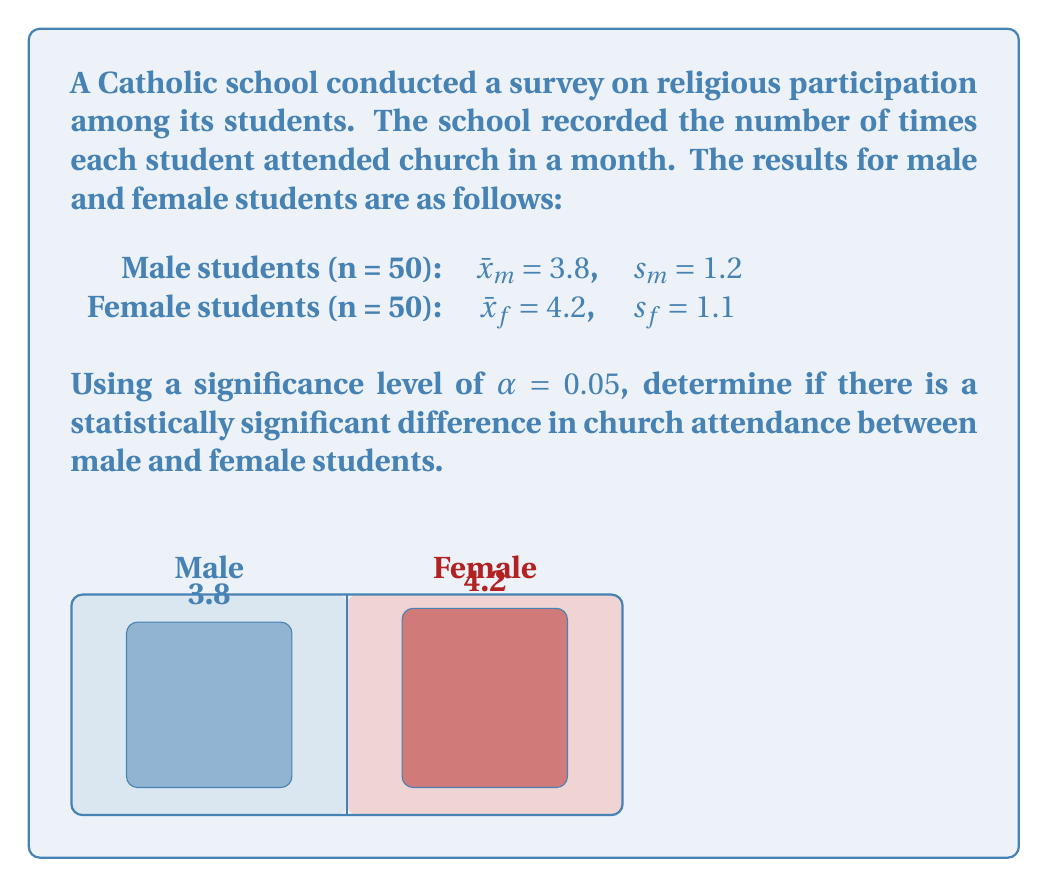Can you answer this question? To determine if there is a statistically significant difference, we'll use a two-sample t-test.

Step 1: State the null and alternative hypotheses
$H_0: \mu_m = \mu_f$ (no difference in means)
$H_a: \mu_m \neq \mu_f$ (there is a difference in means)

Step 2: Calculate the pooled standard deviation
$$s_p = \sqrt{\frac{(n_m - 1)s_m^2 + (n_f - 1)s_f^2}{n_m + n_f - 2}}$$
$$s_p = \sqrt{\frac{(50 - 1)(1.2)^2 + (50 - 1)(1.1)^2}{50 + 50 - 2}} = 1.15$$

Step 3: Calculate the t-statistic
$$t = \frac{\bar{x}_m - \bar{x}_f}{s_p\sqrt{\frac{2}{n}}}$$
$$t = \frac{3.8 - 4.2}{1.15\sqrt{\frac{2}{50}}} = -1.84$$

Step 4: Determine the critical t-value
With $\alpha = 0.05$ and df = 98, the critical t-value is ±1.984 (two-tailed test).

Step 5: Compare the t-statistic to the critical value
|-1.84| < 1.984, so we fail to reject the null hypothesis.

Step 6: Calculate the p-value
Using a t-distribution calculator, we find p ≈ 0.0688 > 0.05
Answer: Fail to reject $H_0$. No statistically significant difference (p ≈ 0.0688). 